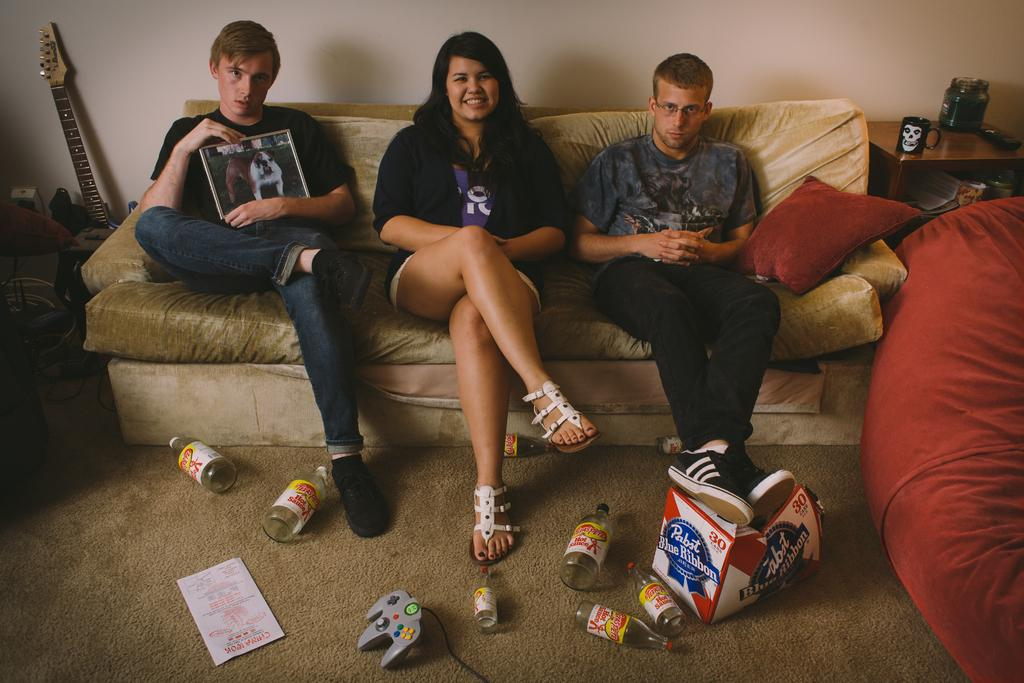<image>
Present a compact description of the photo's key features. Three people on a couch with beer on the ground that says Blue Ribbon. 